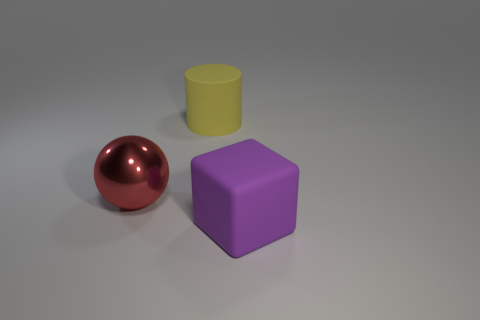Is the large sphere made of the same material as the big purple cube?
Offer a very short reply. No. There is a object that is both in front of the yellow thing and behind the purple thing; what is its size?
Give a very brief answer. Large. What is the shape of the big yellow rubber object?
Your response must be concise. Cylinder. How many things are either large rubber objects or big rubber things that are behind the large shiny thing?
Provide a succinct answer. 2. Do the rubber object that is in front of the yellow cylinder and the metallic object have the same color?
Your answer should be compact. No. There is a object that is in front of the large yellow object and to the right of the large metallic thing; what color is it?
Offer a very short reply. Purple. What is the material of the big purple block in front of the big yellow thing?
Your answer should be very brief. Rubber. What size is the matte cylinder?
Your response must be concise. Large. What number of brown things are either large objects or small spheres?
Keep it short and to the point. 0. How big is the matte object that is behind the large rubber thing that is in front of the cylinder?
Provide a short and direct response. Large. 